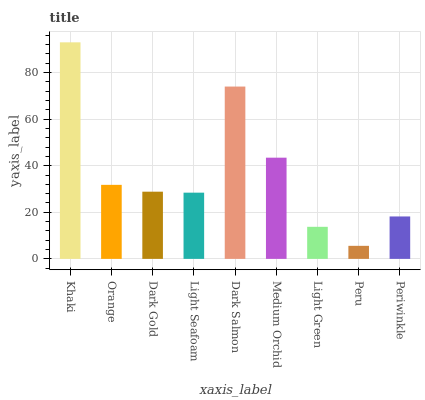Is Peru the minimum?
Answer yes or no. Yes. Is Khaki the maximum?
Answer yes or no. Yes. Is Orange the minimum?
Answer yes or no. No. Is Orange the maximum?
Answer yes or no. No. Is Khaki greater than Orange?
Answer yes or no. Yes. Is Orange less than Khaki?
Answer yes or no. Yes. Is Orange greater than Khaki?
Answer yes or no. No. Is Khaki less than Orange?
Answer yes or no. No. Is Dark Gold the high median?
Answer yes or no. Yes. Is Dark Gold the low median?
Answer yes or no. Yes. Is Light Green the high median?
Answer yes or no. No. Is Dark Salmon the low median?
Answer yes or no. No. 